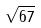Convert formula to latex. <formula><loc_0><loc_0><loc_500><loc_500>\sqrt { 6 7 }</formula> 